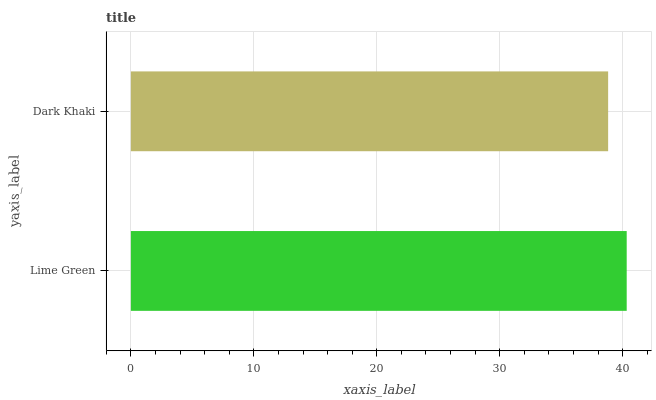Is Dark Khaki the minimum?
Answer yes or no. Yes. Is Lime Green the maximum?
Answer yes or no. Yes. Is Dark Khaki the maximum?
Answer yes or no. No. Is Lime Green greater than Dark Khaki?
Answer yes or no. Yes. Is Dark Khaki less than Lime Green?
Answer yes or no. Yes. Is Dark Khaki greater than Lime Green?
Answer yes or no. No. Is Lime Green less than Dark Khaki?
Answer yes or no. No. Is Lime Green the high median?
Answer yes or no. Yes. Is Dark Khaki the low median?
Answer yes or no. Yes. Is Dark Khaki the high median?
Answer yes or no. No. Is Lime Green the low median?
Answer yes or no. No. 